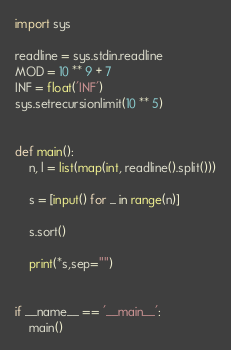Convert code to text. <code><loc_0><loc_0><loc_500><loc_500><_Python_>import sys

readline = sys.stdin.readline
MOD = 10 ** 9 + 7
INF = float('INF')
sys.setrecursionlimit(10 ** 5)


def main():
    n, l = list(map(int, readline().split()))

    s = [input() for _ in range(n)]

    s.sort()

    print(*s,sep="")


if __name__ == '__main__':
    main()
</code> 